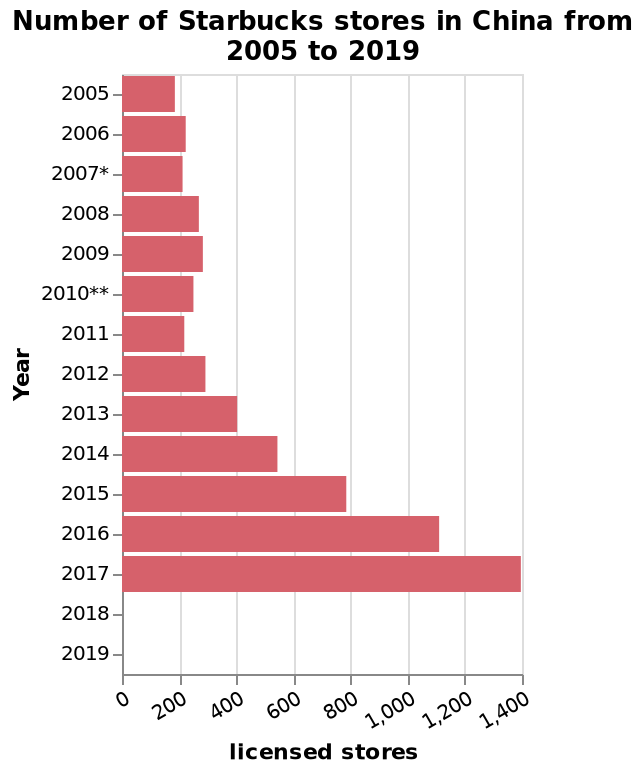<image>
What is the title of the bar graph?  The title of the bar graph is "Number of Starbucks stores in China from 2005 to 2019." How many times more Starbucks were there in China in 2017 compared to 2005?  There were at least 6 times as many Starbucks in 2017 as there were in 2005. Has Starbucks' expansion in China been consistent in recent years? Yes, it has consistently expanded since 2013. Describe the following image in detail This is a bar graph titled Number of Starbucks stores in China from 2005 to 2019. A linear scale with a minimum of 0 and a maximum of 1,400 can be seen on the x-axis, labeled licensed stores. Along the y-axis, Year is shown. What is the range of the x-axis? The range of the x-axis is from 0 to 1,400. Is the range of the x-axis from 1,400 to 0? No.The range of the x-axis is from 0 to 1,400. 